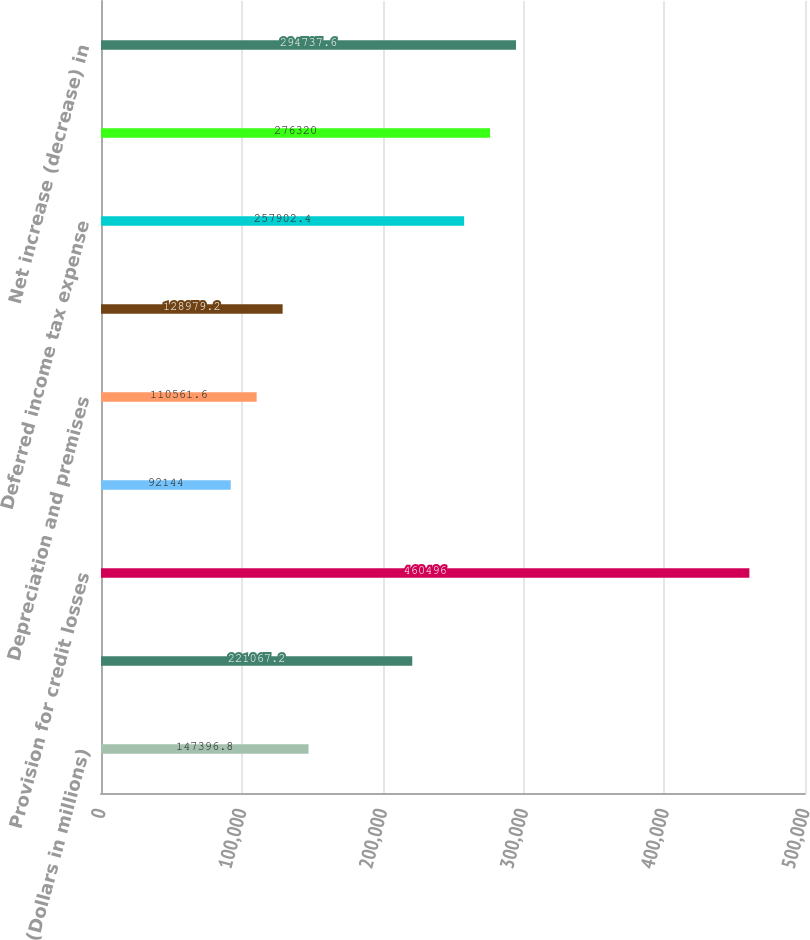<chart> <loc_0><loc_0><loc_500><loc_500><bar_chart><fcel>(Dollars in millions)<fcel>Net income (loss)<fcel>Provision for credit losses<fcel>Gains on sales of debt<fcel>Depreciation and premises<fcel>Amortization of intangibles<fcel>Deferred income tax expense<fcel>Net (increase) decrease in<fcel>Net increase (decrease) in<nl><fcel>147397<fcel>221067<fcel>460496<fcel>92144<fcel>110562<fcel>128979<fcel>257902<fcel>276320<fcel>294738<nl></chart> 